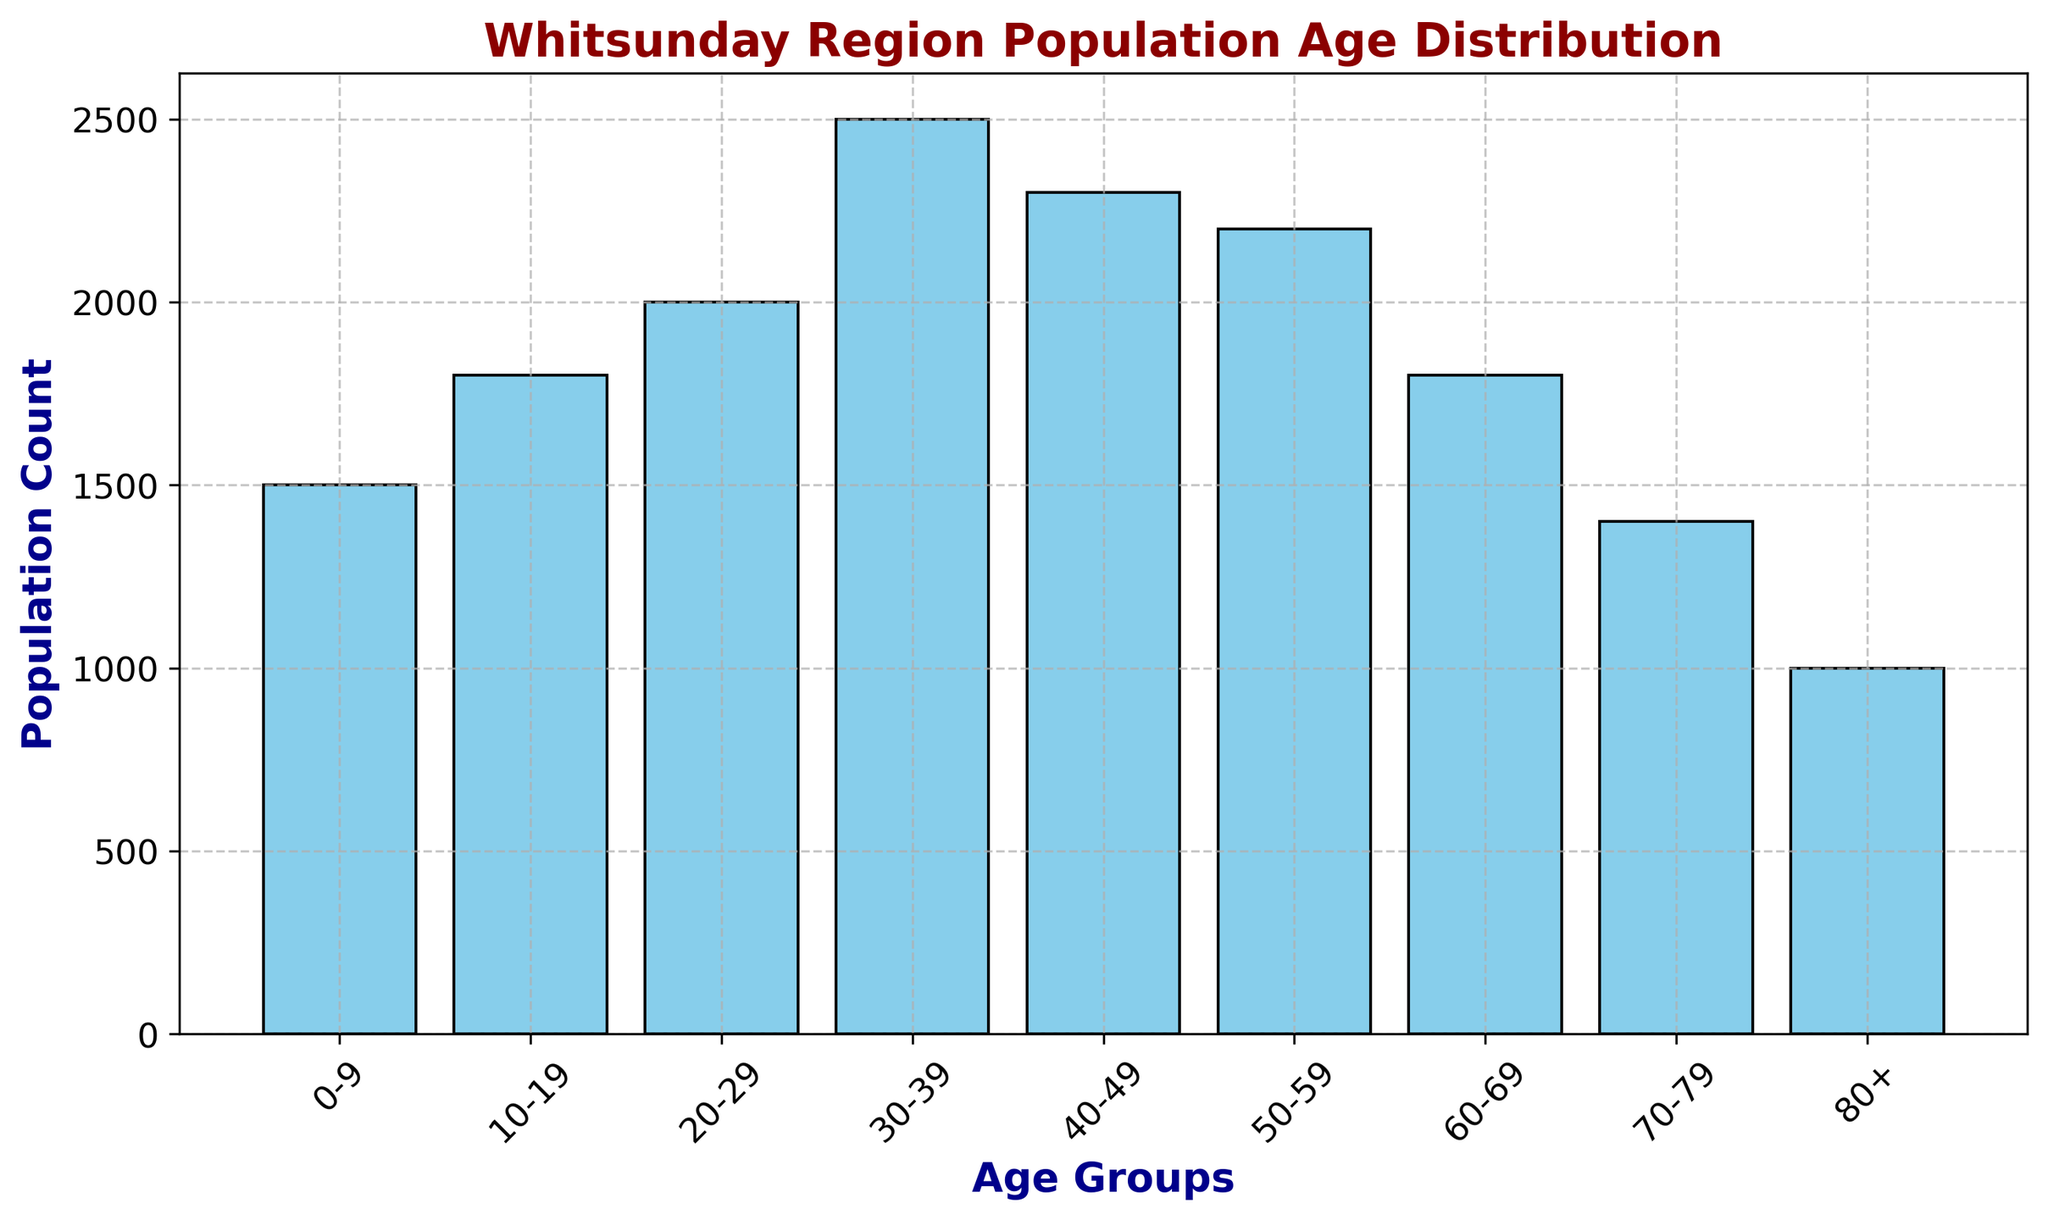What age group has the highest population count? The highest bar on the histogram corresponds to the age group 30-39, indicating this group has the largest population count.
Answer: 30-39 How many people are there in the 50-59 age group? The bar for the 50-59 age group reaches the level marked by the value 2200 on the y-axis, showing the population count for this group.
Answer: 2200 What is the total population of people aged 0-19? Sum the population counts for the 0-9 and 10-19 age groups: 1500 (0-9) + 1800 (10-19) = 3300.
Answer: 3300 Which age group has a lower population count, 40-49 or 60-69? Compare the heights of the bars for the 40-49 and 60-69 age groups: 2300 (40-49) > 1800 (60-69), so 60-69 has a lower count.
Answer: 60-69 How does the population count of the 20-29 age group compare to the 70-79 age group? The bar for the 20-29 age group is taller than the bar for the 70-79 group, indicating 2000 (20-29) > 1400 (70-79).
Answer: 20-29 What is the combined population count for the age groups from 30-49? Sum the population counts for the 30-39 (2500) and 40-49 (2300) age groups: 2500 + 2300 = 4800.
Answer: 4800 Which age group has a smaller population count, 0-9 or 80+? Compare the heights of the bars for the 0-9 and 80+ age groups: 1500 (0-9) > 1000 (80+), so 80+ has a smaller count.
Answer: 80+ What is the difference in population count between the age groups 30-39 and 60-69? Subtract the population count of the 60-69 age group from that of the 30-39 age group: 2500 (30-39) - 1800 (60-69) = 700.
Answer: 700 Which three age groups combined have the highest population count? Identify the three groups: 30-39 (2500), 40-49 (2300), and 50-59 (2200), then sum their counts: 2500 + 2300 + 2200 = 7000.
Answer: 30-59 Do any age groups have the same population count? By comparing the heights of the bars, none of the age groups have the exact same population count.
Answer: No 